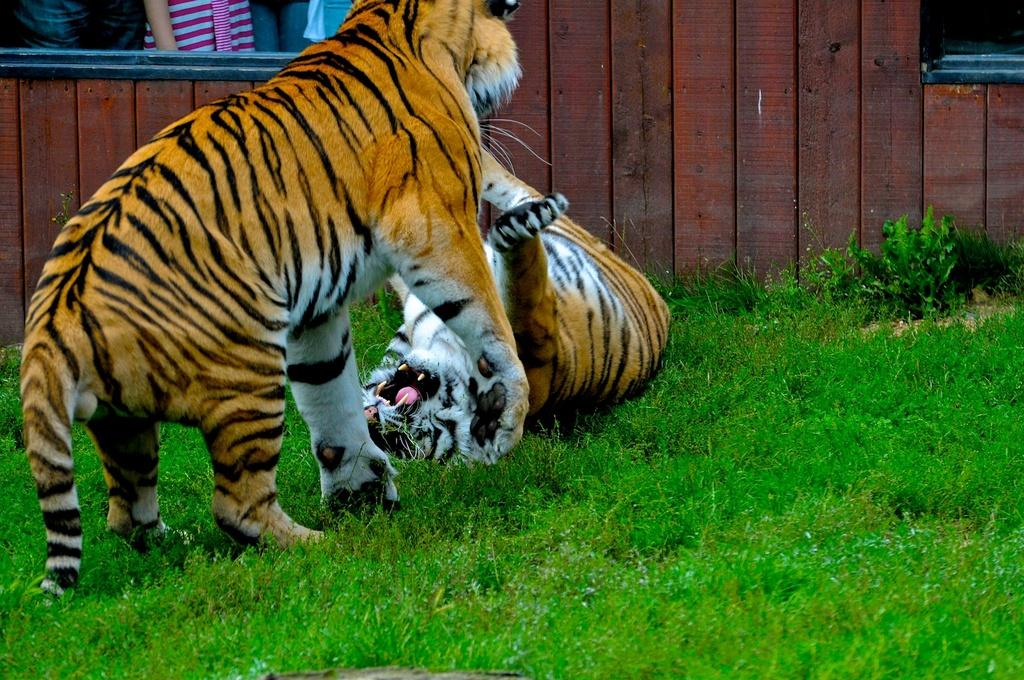How many tigers are in the image? There are two tigers in the image. Where are the tigers located? The tigers are on the ground. What type of surface is the ground made of? There is grass on the ground. What can be seen in the background of the image? There is a wooden wall in the background of the image. What type of brass instrument is being played by the tigers in the image? There is no brass instrument present in the image, as it features two tigers on the ground with grass and a wooden wall in the background. 